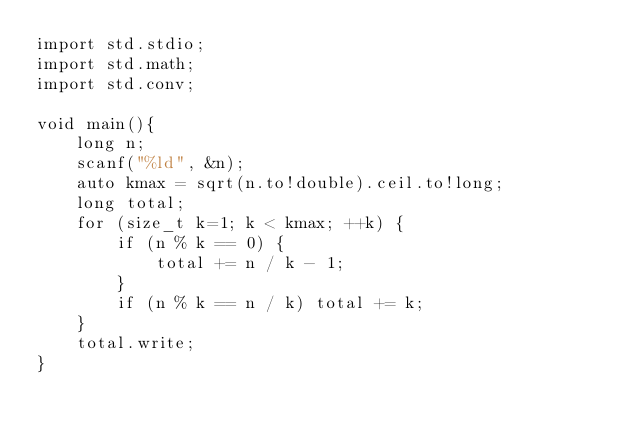<code> <loc_0><loc_0><loc_500><loc_500><_D_>import std.stdio;
import std.math;
import std.conv;

void main(){
	long n;
	scanf("%ld", &n);
	auto kmax = sqrt(n.to!double).ceil.to!long;
	long total;
	for (size_t k=1; k < kmax; ++k) {
		if (n % k == 0) {
			total += n / k - 1;
		}
		if (n % k == n / k) total += k;
	}
	total.write;
}
</code> 